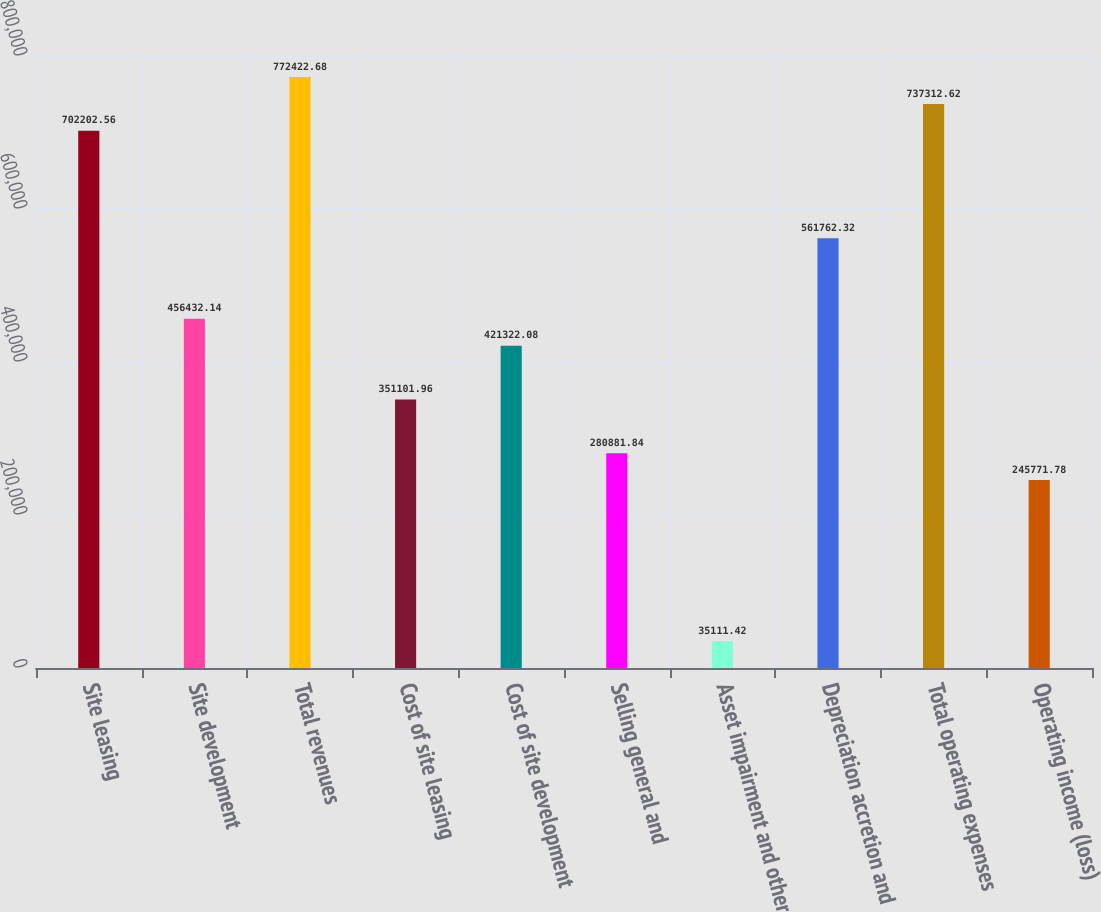Convert chart to OTSL. <chart><loc_0><loc_0><loc_500><loc_500><bar_chart><fcel>Site leasing<fcel>Site development<fcel>Total revenues<fcel>Cost of site leasing<fcel>Cost of site development<fcel>Selling general and<fcel>Asset impairment and other<fcel>Depreciation accretion and<fcel>Total operating expenses<fcel>Operating income (loss)<nl><fcel>702203<fcel>456432<fcel>772423<fcel>351102<fcel>421322<fcel>280882<fcel>35111.4<fcel>561762<fcel>737313<fcel>245772<nl></chart> 